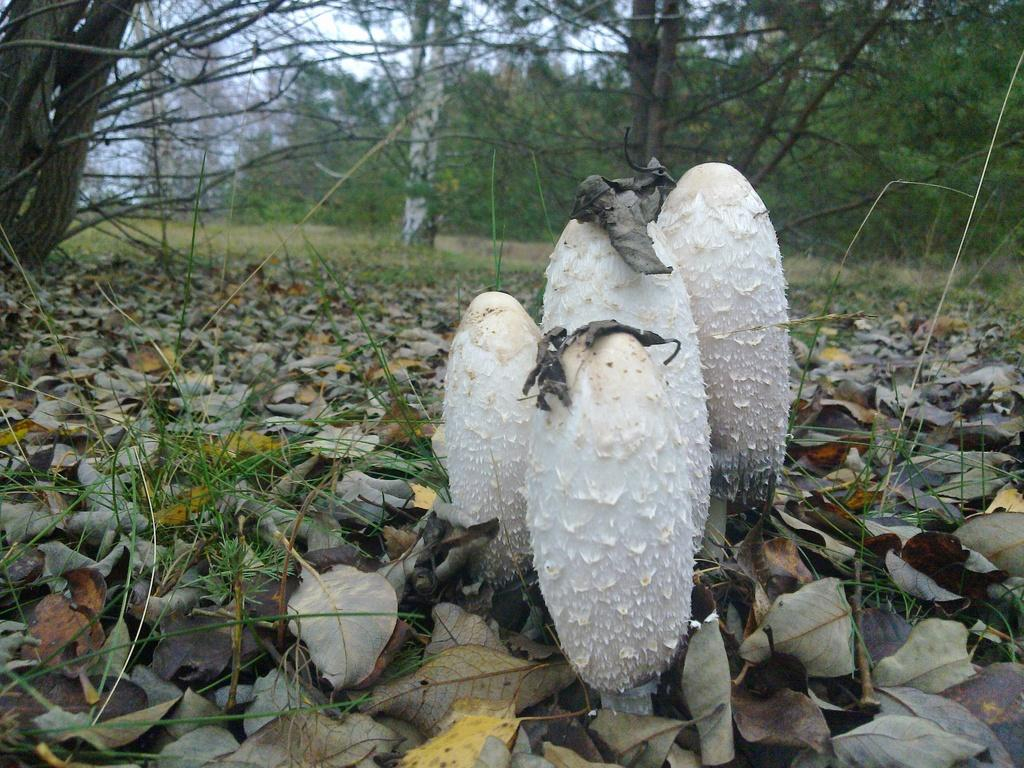What color can be observed in the image? There are white color things in the image. What type of vegetation is present in the image? There are leaves in the image. What can be seen in the background of the image? There are trees, grass, and the sky visible in the background of the image. What book is being read by the tree in the image? There is no book or tree reading a book present in the image. What type of mark can be seen on the leaves in the image? There are no marks visible on the leaves in the image. 